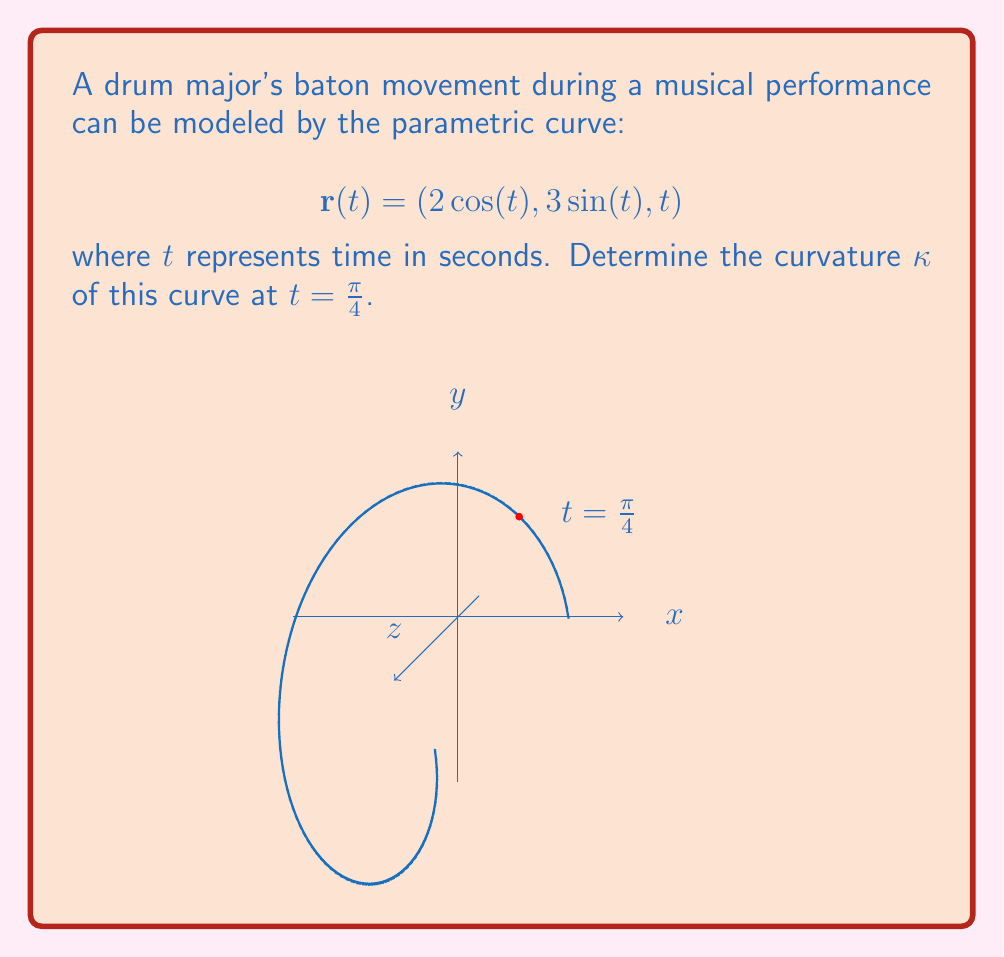Can you answer this question? To find the curvature, we'll use the formula:

$$\kappa = \frac{|\mathbf{r}'(t) \times \mathbf{r}''(t)|}{|\mathbf{r}'(t)|^3}$$

Step 1: Calculate $\mathbf{r}'(t)$
$$\mathbf{r}'(t) = (-2\sin(t), 3\cos(t), 1)$$

Step 2: Calculate $\mathbf{r}''(t)$
$$\mathbf{r}''(t) = (-2\cos(t), -3\sin(t), 0)$$

Step 3: Evaluate $\mathbf{r}'(\frac{\pi}{4})$ and $\mathbf{r}''(\frac{\pi}{4})$
$$\mathbf{r}'(\frac{\pi}{4}) = (-\sqrt{2}, \frac{3\sqrt{2}}{2}, 1)$$
$$\mathbf{r}''(\frac{\pi}{4}) = (-\sqrt{2}, -\frac{3\sqrt{2}}{2}, 0)$$

Step 4: Calculate $\mathbf{r}'(\frac{\pi}{4}) \times \mathbf{r}''(\frac{\pi}{4})$
$$\mathbf{r}'(\frac{\pi}{4}) \times \mathbf{r}''(\frac{\pi}{4}) = \begin{vmatrix} 
\mathbf{i} & \mathbf{j} & \mathbf{k} \\
-\sqrt{2} & \frac{3\sqrt{2}}{2} & 1 \\
-\sqrt{2} & -\frac{3\sqrt{2}}{2} & 0
\end{vmatrix} = (-\frac{3\sqrt{2}}{2}, -\sqrt{2}, -\frac{13}{2})$$

Step 5: Calculate $|\mathbf{r}'(\frac{\pi}{4}) \times \mathbf{r}''(\frac{\pi}{4})|$
$$|\mathbf{r}'(\frac{\pi}{4}) \times \mathbf{r}''(\frac{\pi}{4})| = \sqrt{(\frac{3\sqrt{2}}{2})^2 + (\sqrt{2})^2 + (\frac{13}{2})^2} = \frac{\sqrt{205}}{2}$$

Step 6: Calculate $|\mathbf{r}'(\frac{\pi}{4})|$
$$|\mathbf{r}'(\frac{\pi}{4})| = \sqrt{(\sqrt{2})^2 + (\frac{3\sqrt{2}}{2})^2 + 1^2} = \sqrt{\frac{13}{2}}$$

Step 7: Apply the curvature formula
$$\kappa = \frac{|\mathbf{r}'(\frac{\pi}{4}) \times \mathbf{r}''(\frac{\pi}{4})|}{|\mathbf{r}'(\frac{\pi}{4})|^3} = \frac{\frac{\sqrt{205}}{2}}{(\sqrt{\frac{13}{2}})^3} = \frac{\sqrt{410}}{13\sqrt{13}}$$
Answer: $\frac{\sqrt{410}}{13\sqrt{13}}$ 